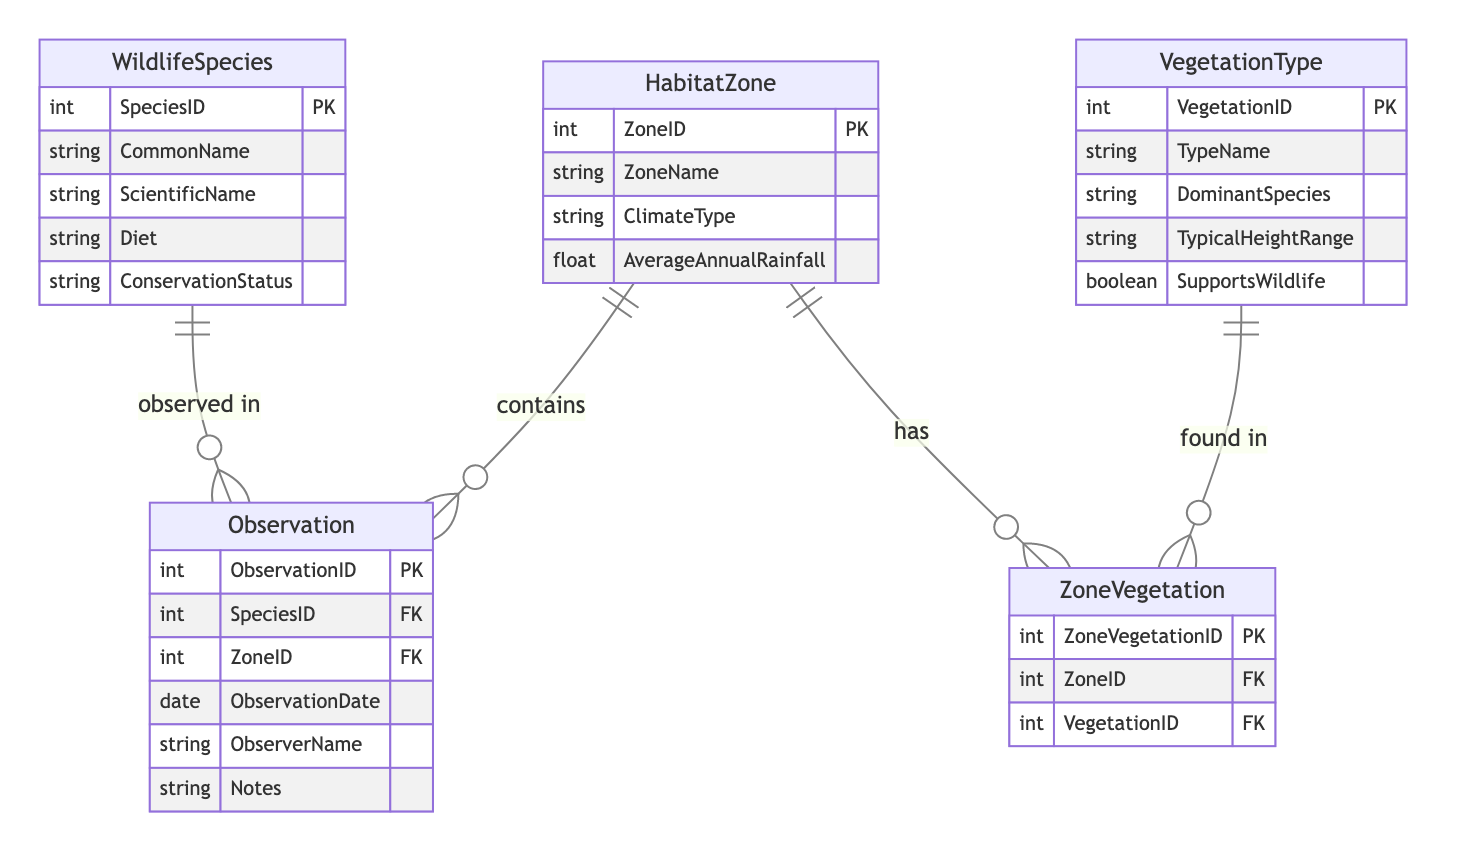What is the primary key of the WildlifeSpecies entity? The primary key for the WildlifeSpecies entity is SpeciesID, as indicated in the entity attributes section of the diagram.
Answer: SpeciesID How many attributes does the HabitatZone entity have? By examining the attributes listed under the HabitatZone entity, we see it has four attributes: ZoneID, ZoneName, ClimateType, and AverageAnnualRainfall. Counting these gives a total of four attributes.
Answer: 4 What relationship type exists between WildlifeSpecies and HabitatZone? The relationship between WildlifeSpecies and HabitatZone is specified as a many-to-many relationship, which is indicated in the relationships section, along with the observation table being the through entity.
Answer: many-to-many What attribute is used as a foreign key in the Observation entity? The Observation entity contains two foreign keys which reference SpeciesID from WildlifeSpecies and ZoneID from HabitatZone. Either of these can be considered a foreign key, while focusing on SpeciesID as the first mentioned in the attributes section.
Answer: SpeciesID How many entities are involved in the ZoneVegetation relationship? The ZoneVegetation relationship consists of two entities: HabitatZone and VegetationType, as indicated in the relationships section of the diagram. Simply counting the mentioned entities gives a total of two.
Answer: 2 What is the relationship type between HabitatZone and VegetationType? The relationship between HabitatZone and VegetationType is defined as many-to-many, detailed in the relationships section of the diagram. Consequently, this means that several habitat zones can contain various vegetation types and vice versa.
Answer: many-to-many Which entity contains the attribute for ObserverName? The attribute ObserverName is located within the Observation entity, as it is specifically listed under its attributes section. This indicates that this entity is responsible for tracking observational data, including who made the observation.
Answer: Observation How does the ZoneVegetation entity link HabitatZone and VegetationType? The ZoneVegetation entity serves as a linking table that contains foreign keys referencing both ZoneID from HabitatZone and VegetationID from VegetationType, signifying that it facilitates the many-to-many relationship between these two entities.
Answer: ZoneVegetation 